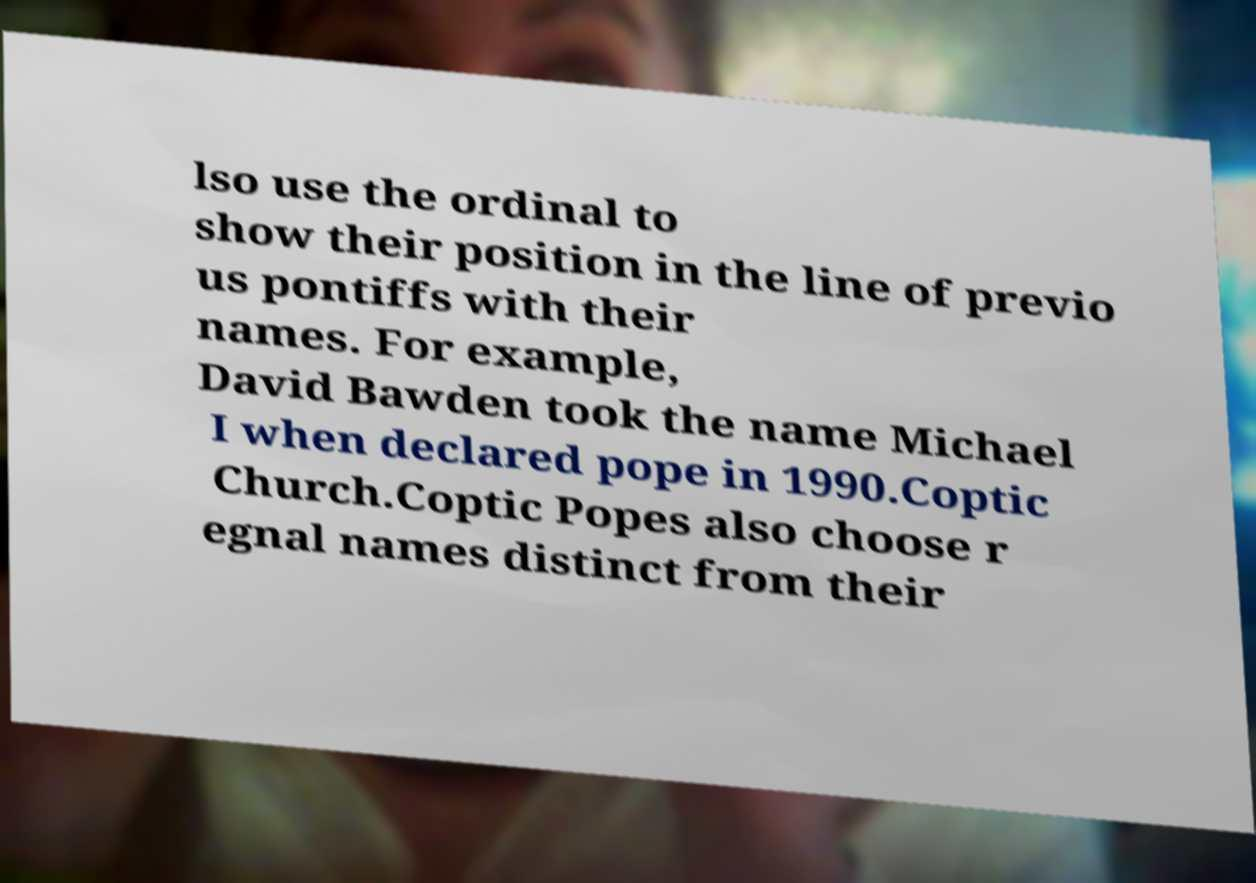There's text embedded in this image that I need extracted. Can you transcribe it verbatim? lso use the ordinal to show their position in the line of previo us pontiffs with their names. For example, David Bawden took the name Michael I when declared pope in 1990.Coptic Church.Coptic Popes also choose r egnal names distinct from their 